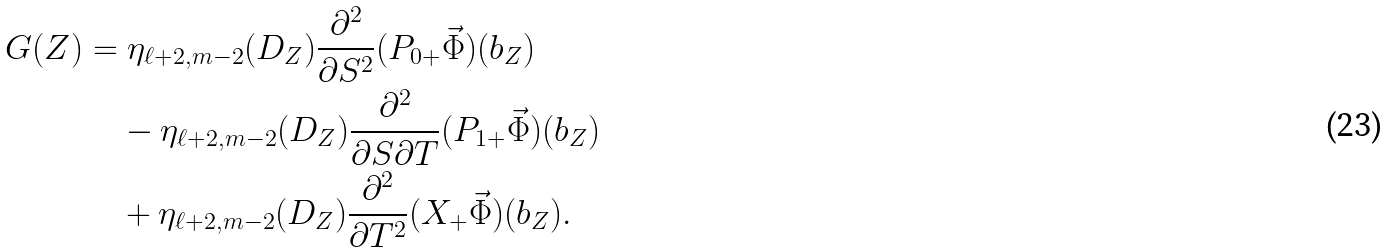Convert formula to latex. <formula><loc_0><loc_0><loc_500><loc_500>G ( Z ) & = \eta _ { \ell + 2 , m - 2 } ( D _ { Z } ) \frac { \partial ^ { 2 } } { \partial S ^ { 2 } } ( P _ { 0 + } \vec { \Phi } ) ( b _ { Z } ) \\ & \quad - \eta _ { \ell + 2 , m - 2 } ( D _ { Z } ) \frac { \partial ^ { 2 } } { \partial S \partial T } ( P _ { 1 + } \vec { \Phi } ) ( b _ { Z } ) \\ & \quad + \eta _ { \ell + 2 , m - 2 } ( D _ { Z } ) \frac { \partial ^ { 2 } } { \partial T ^ { 2 } } ( X _ { + } \vec { \Phi } ) ( b _ { Z } ) .</formula> 